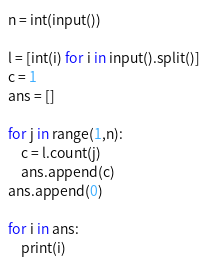Convert code to text. <code><loc_0><loc_0><loc_500><loc_500><_Python_>n = int(input())

l = [int(i) for i in input().split()]
c = 1
ans = []

for j in range(1,n):
    c = l.count(j)
    ans.append(c)
ans.append(0)

for i in ans:
    print(i)
</code> 